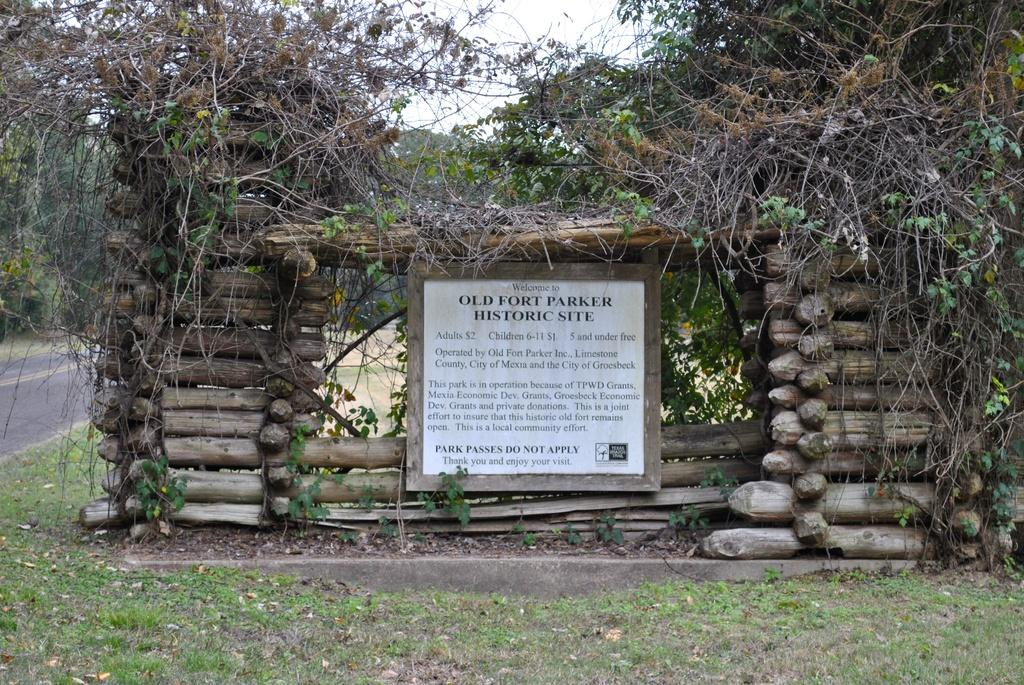What is located in the center of the image? There is a shed with logs in the center of the image. What can be seen on the board in the image? There is a board with text in the image. What type of natural environment is visible in the background of the image? There are trees in the background of the image. What is visible at the bottom of the image? The ground and a road are visible at the bottom of the image. How many arms are visible on the person in the image? There is no person present in the image, so no arms can be seen. 